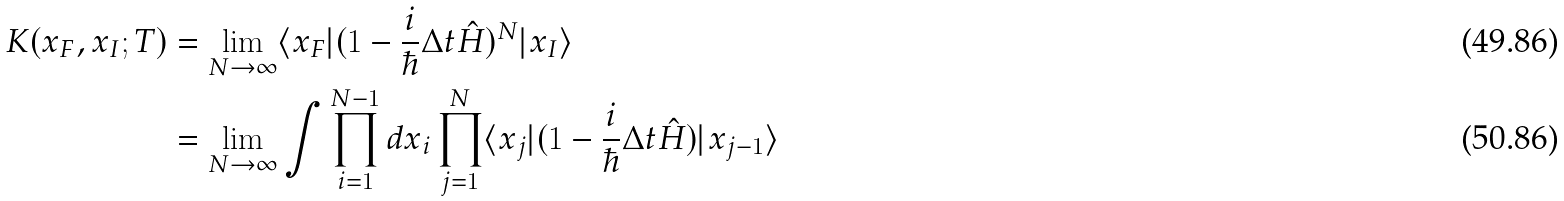Convert formula to latex. <formula><loc_0><loc_0><loc_500><loc_500>K ( x _ { F } , x _ { I } ; T ) & = \lim _ { N \to \infty } \langle x _ { F } | ( 1 - \frac { i } { \hbar } { \Delta } t \hat { H } ) ^ { N } | x _ { I } \rangle \\ & = \lim _ { N \to \infty } \int \prod _ { i = 1 } ^ { N - 1 } d x _ { i } \prod _ { j = 1 } ^ { N } \langle x _ { j } | ( 1 - \frac { i } { \hbar } { \Delta } t \hat { H } ) | x _ { j - 1 } \rangle</formula> 